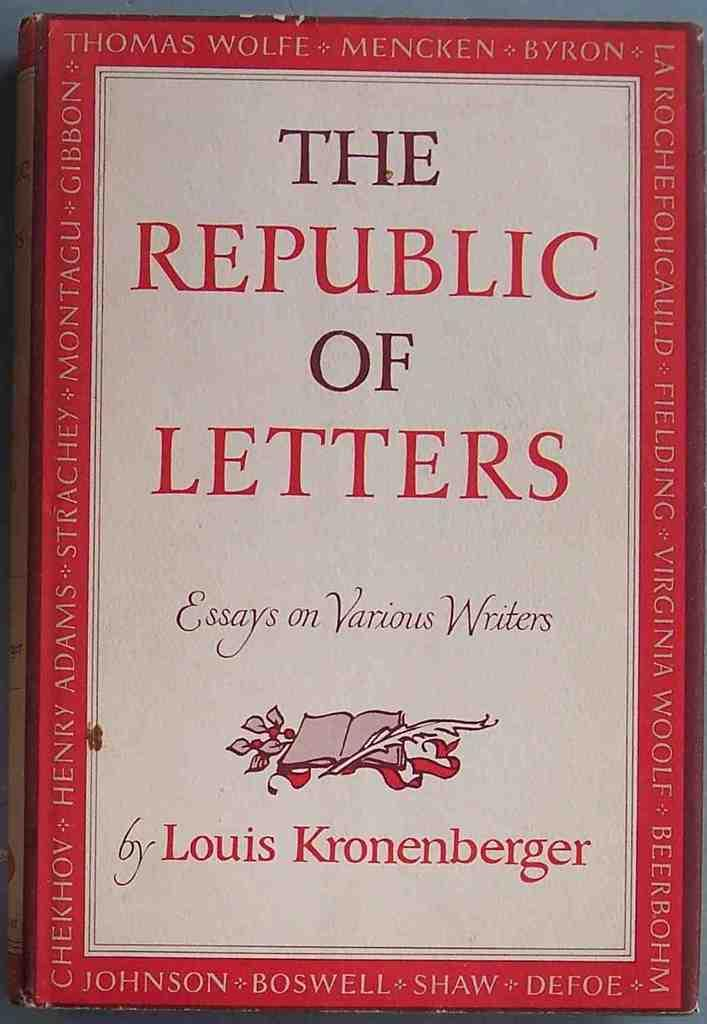<image>
Present a compact description of the photo's key features. The Republic of Letters was written by Louis Kronenberger 